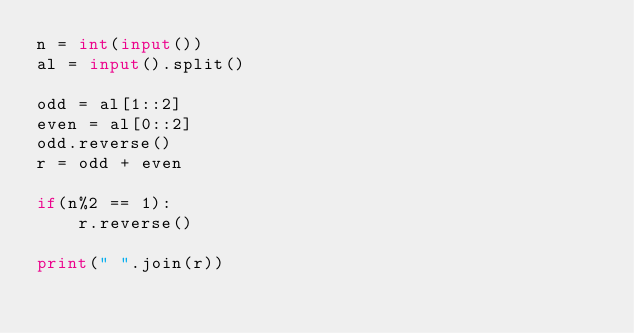<code> <loc_0><loc_0><loc_500><loc_500><_Python_>n = int(input())
al = input().split()

odd = al[1::2]
even = al[0::2]
odd.reverse()
r = odd + even

if(n%2 == 1):
    r.reverse()

print(" ".join(r))</code> 